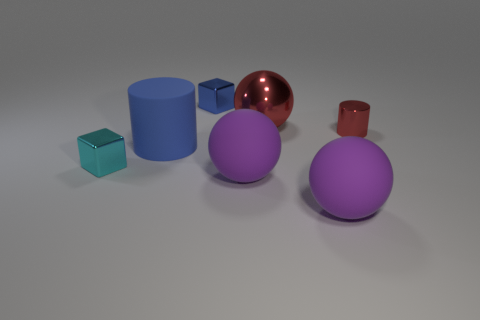What is the shape of the blue object behind the small red cylinder?
Your answer should be compact. Cube. How many blue metal cubes are on the left side of the sphere that is behind the cube in front of the metallic sphere?
Keep it short and to the point. 1. Do the rubber object to the left of the blue shiny thing and the big metallic object have the same color?
Offer a very short reply. No. How many other objects are there of the same shape as the big shiny thing?
Provide a short and direct response. 2. How many other things are the same material as the red cylinder?
Provide a short and direct response. 3. What is the tiny thing that is to the left of the block to the right of the block in front of the small metallic cylinder made of?
Provide a succinct answer. Metal. Do the blue block and the small red thing have the same material?
Make the answer very short. Yes. What number of spheres are large green objects or big rubber things?
Ensure brevity in your answer.  2. There is a sphere to the right of the large red thing; what color is it?
Provide a succinct answer. Purple. How many metallic objects are big spheres or tiny green spheres?
Make the answer very short. 1. 